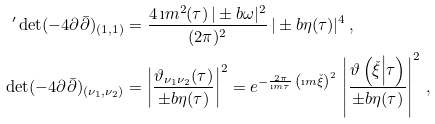Convert formula to latex. <formula><loc_0><loc_0><loc_500><loc_500>{ ^ { \prime } } \det ( - 4 \partial \bar { \partial } ) _ { ( 1 , 1 ) } & = \frac { 4 \, \i m ^ { 2 } ( \tau ) \, | \pm b { \omega } | ^ { 2 } } { ( 2 \pi ) ^ { 2 } } \, | \pm b { \eta } ( \tau ) | ^ { 4 } \, , \\ \det ( - 4 \partial \bar { \partial } ) _ { ( \nu _ { 1 } , \nu _ { 2 } ) } & = \left | \frac { \vartheta _ { \nu _ { 1 } \nu _ { 2 } } ( \tau ) } { \pm b { \eta } ( \tau ) } \right | ^ { 2 } = e ^ { - \frac { 2 \pi } { \i m \tau } \, \left ( \i m \check { \xi } \right ) ^ { 2 } } \, \left | \frac { \vartheta \left ( \check { \xi } \Big | \tau \right ) } { \pm b { \eta } ( \tau ) } \right | ^ { 2 } \, ,</formula> 